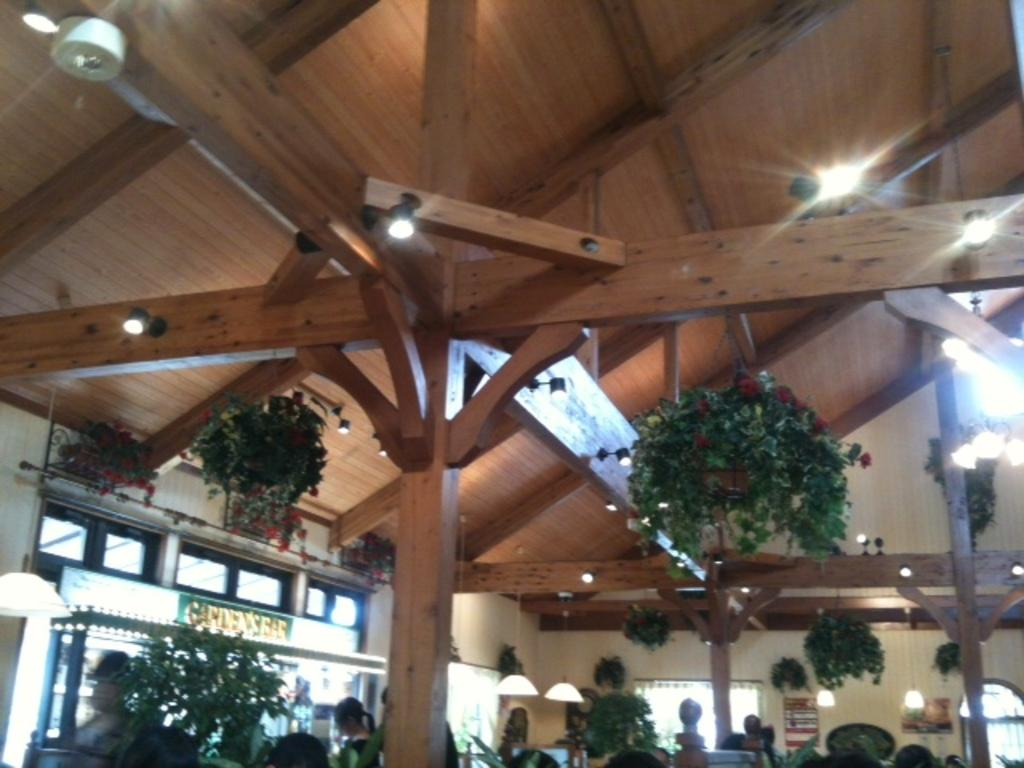What type of material is used for the poles and roof in the image? The poles and roof in the image are made of wood. What is located under the wooden roof? There are plants under the roof in the image. What can be seen in the image that provides illumination? There are lights in the image. Are there any people present in the image? Yes, there are people in the image. What type of chalk is being used by the people in the image? There is no chalk present in the image; the people are not using any chalk. What type of card is being held by the plants in the image? There are no cards present in the image; the plants are not holding any cards. 